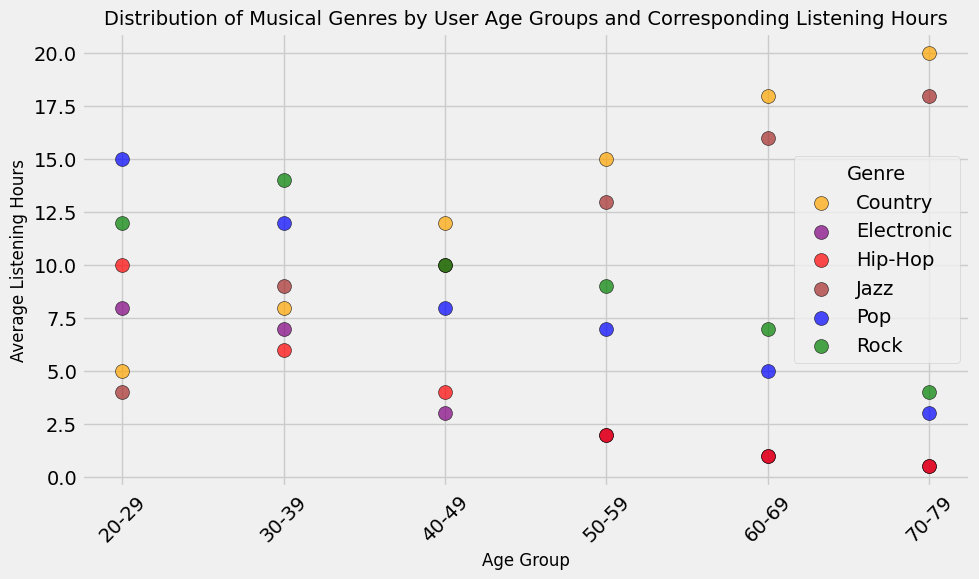Which age group spends the most average listening hours on Country music? The scatter plot uses colors to differentiate genres, with orange representing Country music. By looking at the orange dots' vertical positions, the 70-79 age group has the highest average listening hours for Country music at 20 hours.
Answer: 70-79 Which genre is most popular among the 30-39 age group? To find the most popular genre for the 30-39 age group, locate the age group on the x-axis, and then observe the dots' heights. Rock (green) has the highest average listening hours at 14 hours.
Answer: Rock How does the listening pattern for Jazz change across different age groups? By following the brown dots representing Jazz across the x-axis, you can see that listening hours generally increase with age, peaking at 18 hours for the 70-79 age group.
Answer: Increases Compare the listening hours for Pop in the 20-29 and 60-69 age groups. Which group listens more? Find the blue dot for Pop in the 20-29 age group, which is at 15 hours, and compare it to the blue dot in the 60-69 age group at 5 hours. The 20-29 age group listens more.
Answer: 20-29 What is the combined average listening hours for Electronic music in the 40-49 age group and the 50-59 age group? Look for the purple dots representing Electronic music in both age groups: 3 hours for 40-49 and 2 hours for 50-59. The combined total is 3 + 2 = 5 hours.
Answer: 5 hours Which genre has the least listening hours in the 70-79 age group? Observe the dots in the 70-79 age group; the red and purple dots (Hip-Hop and Electronic) are the lowest at 0.5 hours each.
Answer: Hip-Hop and Electronic Between the age groups 20-29 and 50-59, which has a higher average listening hour for Jazz? Locate the brown dots for Jazz in both age groups: 20-29 at 4 hours and 50-59 at 13 hours. The 50-59 age group listens more.
Answer: 50-59 Calculate the difference in listening hours for Country music between the 40-49 and 60-69 age groups. Refer to the orange dots for Country music: 12 hours for the 40-49 group and 18 hours for 60-69. The difference is 18 - 12 = 6 hours.
Answer: 6 hours 